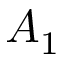<formula> <loc_0><loc_0><loc_500><loc_500>A _ { 1 }</formula> 